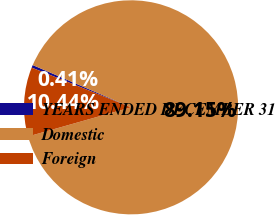<chart> <loc_0><loc_0><loc_500><loc_500><pie_chart><fcel>YEARS ENDED DECEMBER 31<fcel>Domestic<fcel>Foreign<nl><fcel>0.41%<fcel>89.16%<fcel>10.44%<nl></chart> 